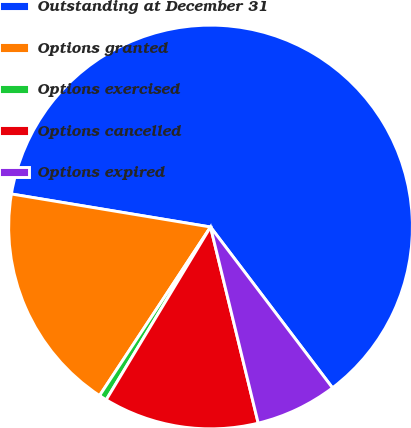<chart> <loc_0><loc_0><loc_500><loc_500><pie_chart><fcel>Outstanding at December 31<fcel>Options granted<fcel>Options exercised<fcel>Options cancelled<fcel>Options expired<nl><fcel>62.06%<fcel>18.35%<fcel>0.62%<fcel>12.44%<fcel>6.53%<nl></chart> 